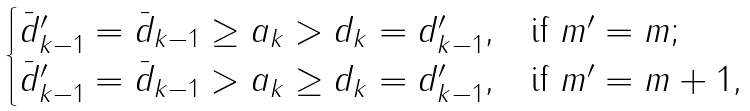Convert formula to latex. <formula><loc_0><loc_0><loc_500><loc_500>\begin{cases} \bar { d } ^ { \prime } _ { k - 1 } = \bar { d } _ { k - 1 } \geq a _ { k } > d _ { k } = d ^ { \prime } _ { k - 1 } , & \text {if $m^{\prime}=m$} ; \\ \bar { d } ^ { \prime } _ { k - 1 } = \bar { d } _ { k - 1 } > a _ { k } \geq d _ { k } = d ^ { \prime } _ { k - 1 } , & \text {if $m^{\prime}=m+1$} , \end{cases}</formula> 